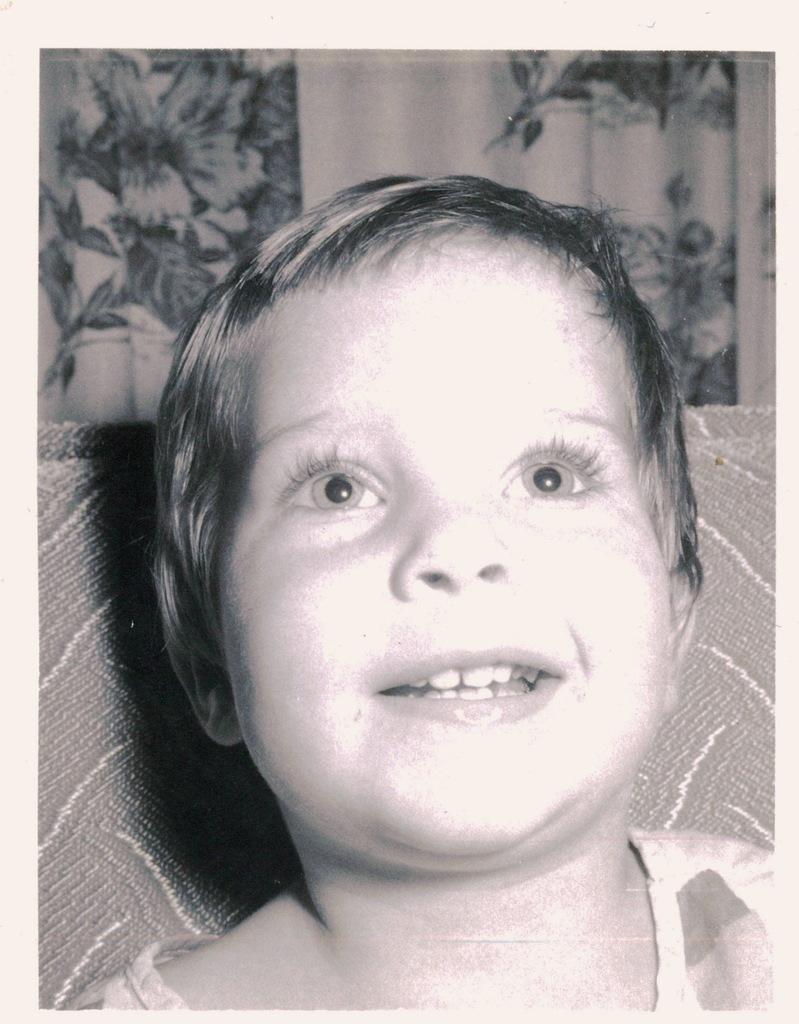What is the main subject of the image? The main subject of the image is a kid. Can you describe anything in the background of the image? Yes, there is a cloth in the background of the image. What type of operation is the kid performing on their friend in the image? There is no friend present in the image, and no operation is being performed. 